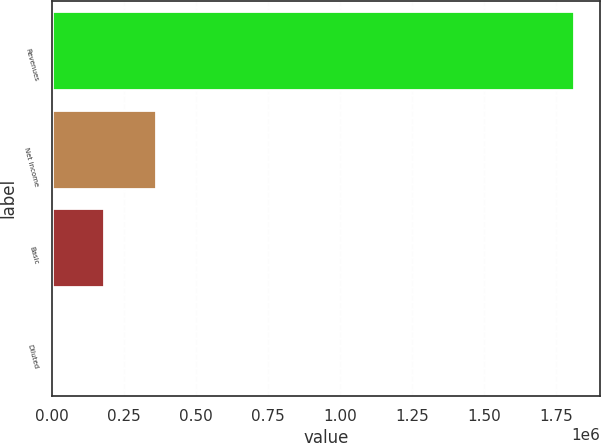Convert chart to OTSL. <chart><loc_0><loc_0><loc_500><loc_500><bar_chart><fcel>Revenues<fcel>Net income<fcel>Basic<fcel>Diluted<nl><fcel>1.81106e+06<fcel>362212<fcel>181106<fcel>0.85<nl></chart> 